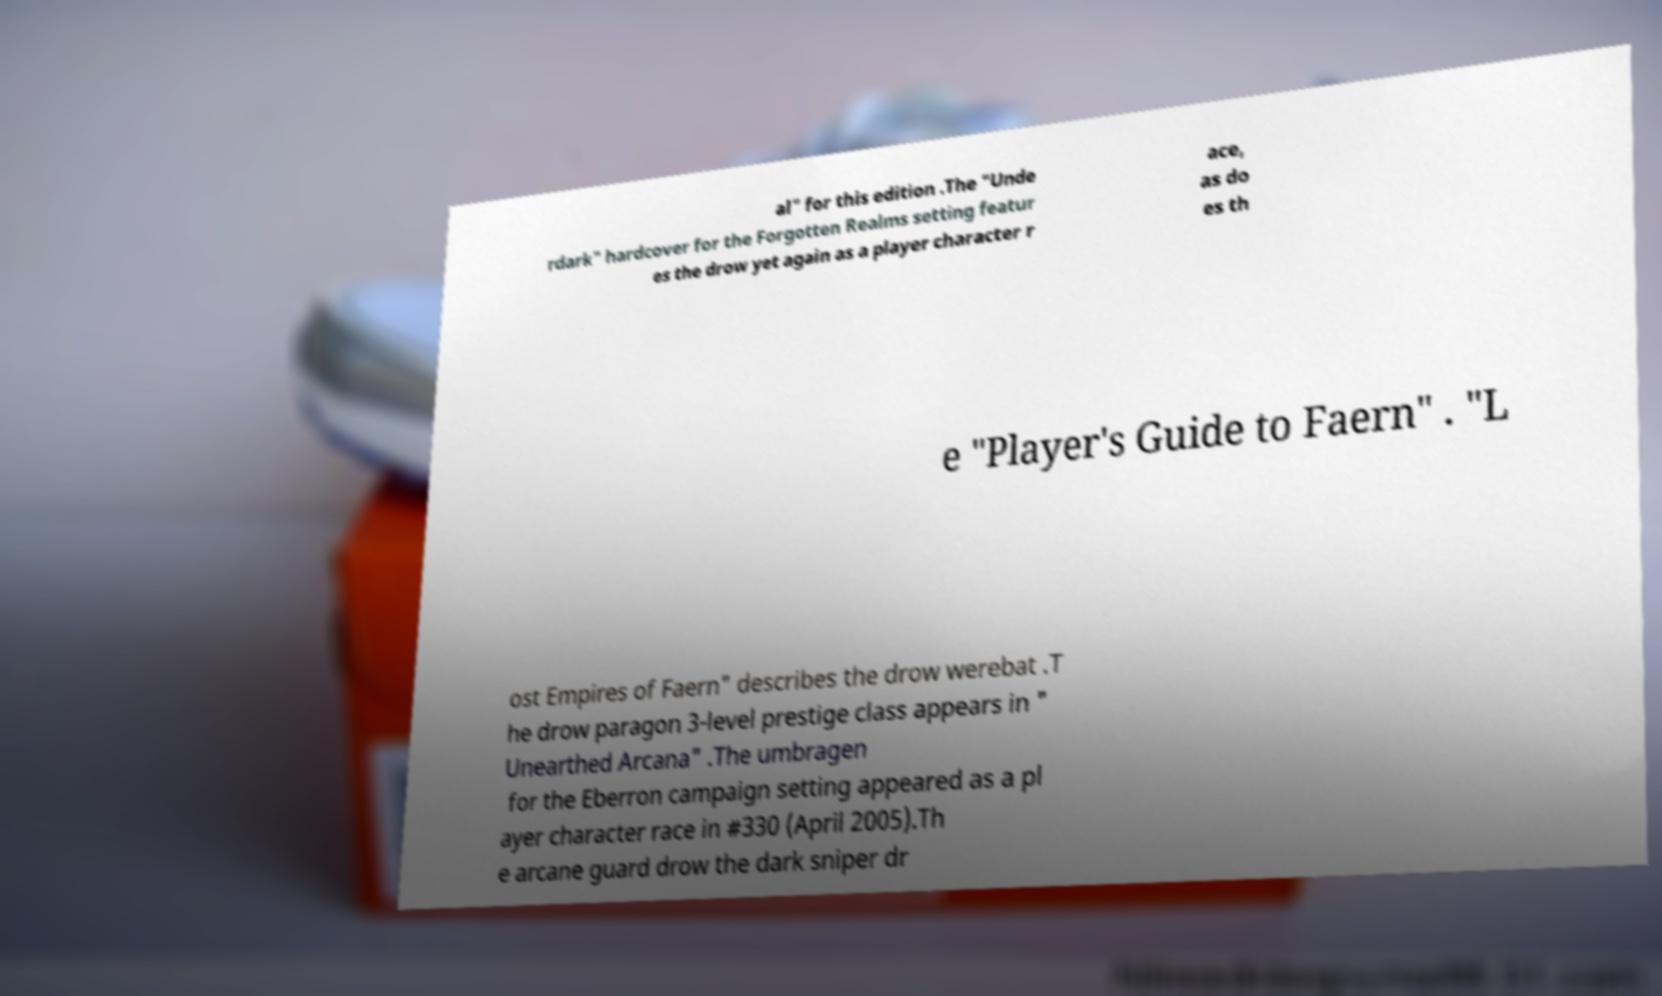Could you extract and type out the text from this image? al" for this edition .The "Unde rdark" hardcover for the Forgotten Realms setting featur es the drow yet again as a player character r ace, as do es th e "Player's Guide to Faern" . "L ost Empires of Faern" describes the drow werebat .T he drow paragon 3-level prestige class appears in " Unearthed Arcana" .The umbragen for the Eberron campaign setting appeared as a pl ayer character race in #330 (April 2005).Th e arcane guard drow the dark sniper dr 